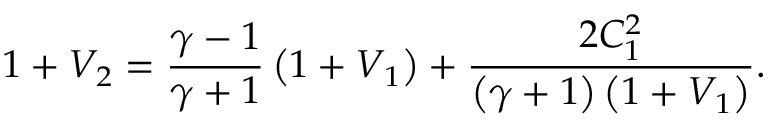Convert formula to latex. <formula><loc_0><loc_0><loc_500><loc_500>1 + V _ { 2 } = \frac { \gamma - 1 } { \gamma + 1 } \left ( 1 + V _ { 1 } \right ) + \frac { 2 C _ { 1 } ^ { 2 } } { \left ( \gamma + 1 \right ) \left ( 1 + V _ { 1 } \right ) } .</formula> 